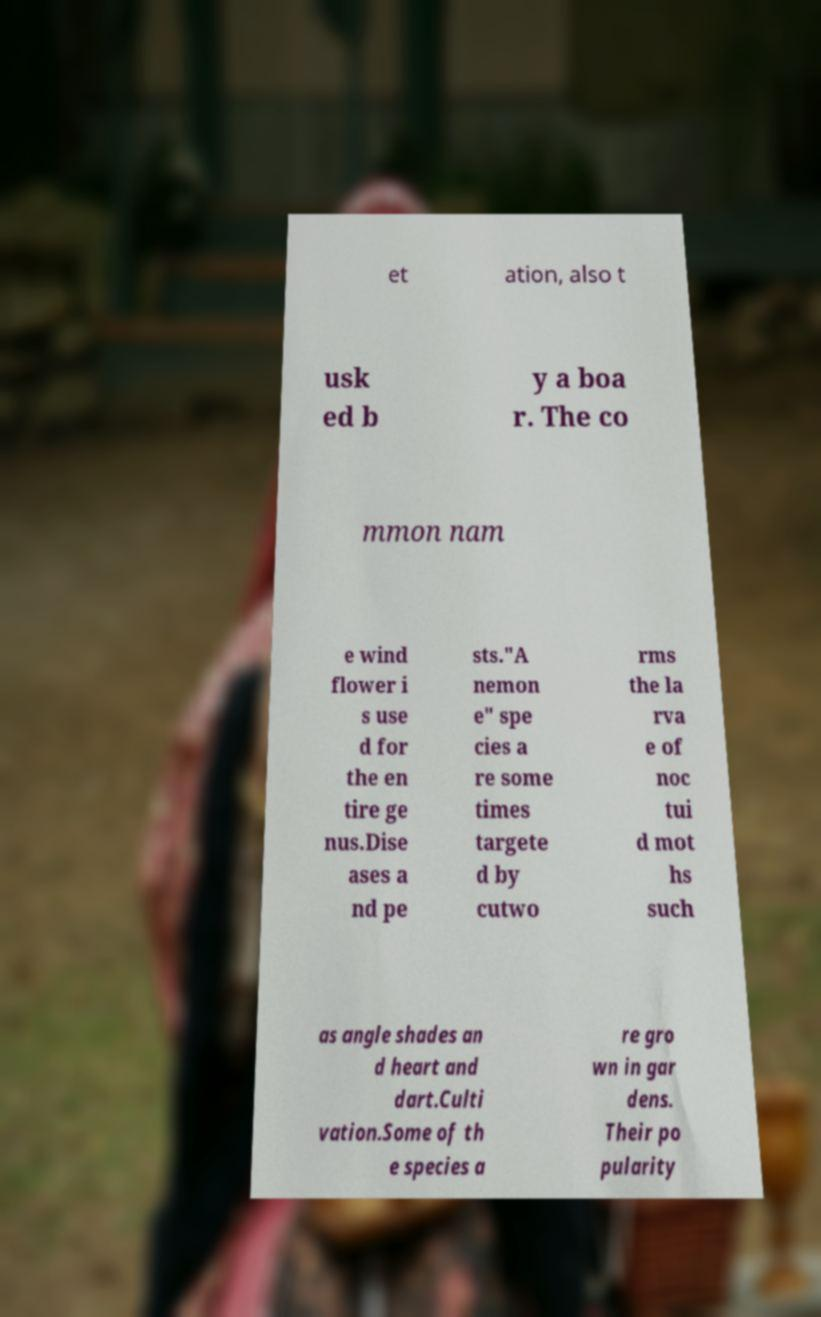Please identify and transcribe the text found in this image. et ation, also t usk ed b y a boa r. The co mmon nam e wind flower i s use d for the en tire ge nus.Dise ases a nd pe sts."A nemon e" spe cies a re some times targete d by cutwo rms the la rva e of noc tui d mot hs such as angle shades an d heart and dart.Culti vation.Some of th e species a re gro wn in gar dens. Their po pularity 